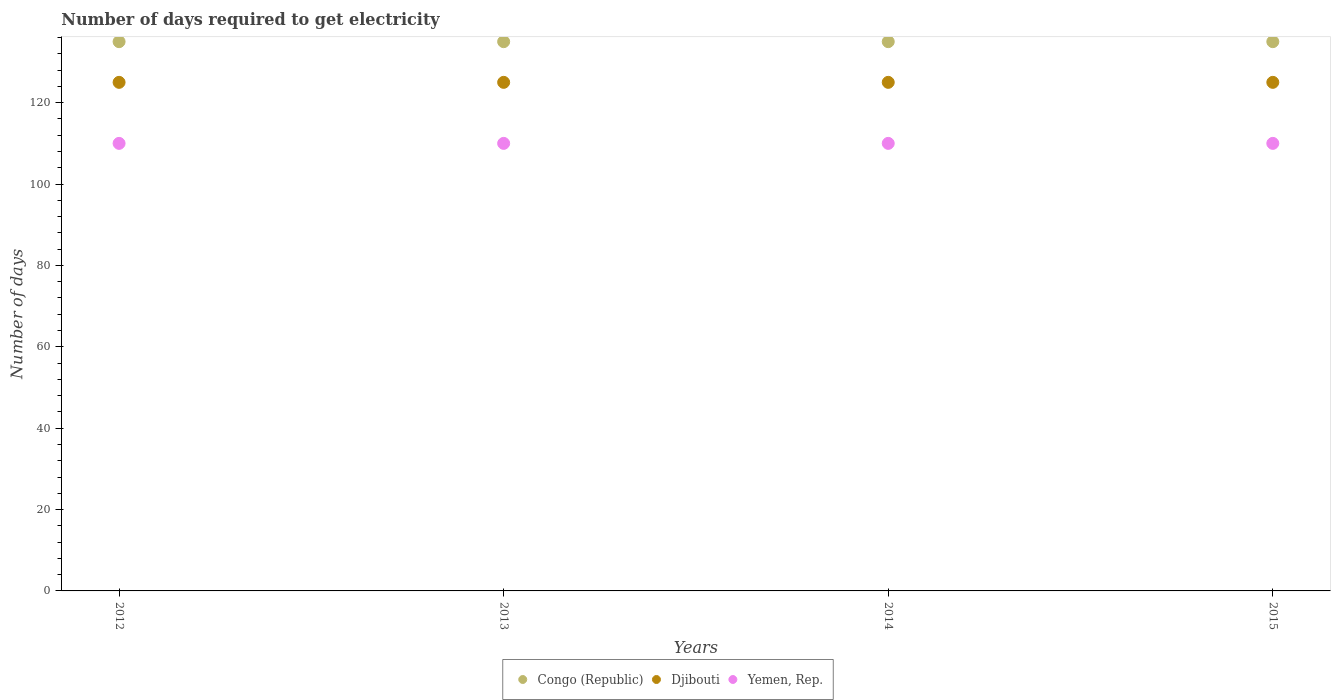How many different coloured dotlines are there?
Keep it short and to the point. 3. What is the number of days required to get electricity in in Congo (Republic) in 2015?
Offer a terse response. 135. Across all years, what is the maximum number of days required to get electricity in in Djibouti?
Ensure brevity in your answer.  125. Across all years, what is the minimum number of days required to get electricity in in Djibouti?
Your response must be concise. 125. In which year was the number of days required to get electricity in in Congo (Republic) maximum?
Your answer should be very brief. 2012. What is the total number of days required to get electricity in in Congo (Republic) in the graph?
Your answer should be very brief. 540. What is the difference between the number of days required to get electricity in in Yemen, Rep. in 2015 and the number of days required to get electricity in in Congo (Republic) in 2013?
Offer a very short reply. -25. What is the average number of days required to get electricity in in Congo (Republic) per year?
Ensure brevity in your answer.  135. In the year 2012, what is the difference between the number of days required to get electricity in in Congo (Republic) and number of days required to get electricity in in Yemen, Rep.?
Ensure brevity in your answer.  25. Is the difference between the number of days required to get electricity in in Congo (Republic) in 2013 and 2015 greater than the difference between the number of days required to get electricity in in Yemen, Rep. in 2013 and 2015?
Offer a very short reply. No. Is the sum of the number of days required to get electricity in in Djibouti in 2012 and 2015 greater than the maximum number of days required to get electricity in in Yemen, Rep. across all years?
Ensure brevity in your answer.  Yes. Does the number of days required to get electricity in in Djibouti monotonically increase over the years?
Offer a terse response. No. Is the number of days required to get electricity in in Congo (Republic) strictly greater than the number of days required to get electricity in in Yemen, Rep. over the years?
Make the answer very short. Yes. How many dotlines are there?
Make the answer very short. 3. What is the difference between two consecutive major ticks on the Y-axis?
Your answer should be very brief. 20. Does the graph contain grids?
Give a very brief answer. No. Where does the legend appear in the graph?
Your answer should be very brief. Bottom center. How are the legend labels stacked?
Offer a terse response. Horizontal. What is the title of the graph?
Provide a short and direct response. Number of days required to get electricity. Does "Peru" appear as one of the legend labels in the graph?
Ensure brevity in your answer.  No. What is the label or title of the X-axis?
Your answer should be compact. Years. What is the label or title of the Y-axis?
Ensure brevity in your answer.  Number of days. What is the Number of days of Congo (Republic) in 2012?
Offer a terse response. 135. What is the Number of days of Djibouti in 2012?
Offer a very short reply. 125. What is the Number of days of Yemen, Rep. in 2012?
Offer a terse response. 110. What is the Number of days of Congo (Republic) in 2013?
Your response must be concise. 135. What is the Number of days in Djibouti in 2013?
Provide a succinct answer. 125. What is the Number of days of Yemen, Rep. in 2013?
Your answer should be very brief. 110. What is the Number of days in Congo (Republic) in 2014?
Offer a terse response. 135. What is the Number of days of Djibouti in 2014?
Offer a terse response. 125. What is the Number of days of Yemen, Rep. in 2014?
Your answer should be very brief. 110. What is the Number of days in Congo (Republic) in 2015?
Make the answer very short. 135. What is the Number of days in Djibouti in 2015?
Offer a terse response. 125. What is the Number of days of Yemen, Rep. in 2015?
Give a very brief answer. 110. Across all years, what is the maximum Number of days of Congo (Republic)?
Offer a terse response. 135. Across all years, what is the maximum Number of days in Djibouti?
Give a very brief answer. 125. Across all years, what is the maximum Number of days of Yemen, Rep.?
Give a very brief answer. 110. Across all years, what is the minimum Number of days in Congo (Republic)?
Your response must be concise. 135. Across all years, what is the minimum Number of days of Djibouti?
Keep it short and to the point. 125. Across all years, what is the minimum Number of days of Yemen, Rep.?
Offer a very short reply. 110. What is the total Number of days in Congo (Republic) in the graph?
Provide a succinct answer. 540. What is the total Number of days in Yemen, Rep. in the graph?
Keep it short and to the point. 440. What is the difference between the Number of days of Congo (Republic) in 2012 and that in 2013?
Provide a short and direct response. 0. What is the difference between the Number of days in Congo (Republic) in 2012 and that in 2015?
Give a very brief answer. 0. What is the difference between the Number of days in Congo (Republic) in 2013 and that in 2015?
Provide a short and direct response. 0. What is the difference between the Number of days in Djibouti in 2013 and that in 2015?
Offer a terse response. 0. What is the difference between the Number of days of Yemen, Rep. in 2013 and that in 2015?
Give a very brief answer. 0. What is the difference between the Number of days in Congo (Republic) in 2014 and that in 2015?
Offer a terse response. 0. What is the difference between the Number of days in Djibouti in 2014 and that in 2015?
Offer a terse response. 0. What is the difference between the Number of days in Yemen, Rep. in 2014 and that in 2015?
Give a very brief answer. 0. What is the difference between the Number of days in Congo (Republic) in 2012 and the Number of days in Djibouti in 2013?
Keep it short and to the point. 10. What is the difference between the Number of days of Congo (Republic) in 2012 and the Number of days of Yemen, Rep. in 2013?
Provide a succinct answer. 25. What is the difference between the Number of days of Congo (Republic) in 2012 and the Number of days of Djibouti in 2014?
Ensure brevity in your answer.  10. What is the difference between the Number of days in Congo (Republic) in 2012 and the Number of days in Djibouti in 2015?
Offer a terse response. 10. What is the difference between the Number of days of Djibouti in 2012 and the Number of days of Yemen, Rep. in 2015?
Keep it short and to the point. 15. What is the difference between the Number of days in Congo (Republic) in 2013 and the Number of days in Djibouti in 2014?
Your answer should be compact. 10. What is the difference between the Number of days of Congo (Republic) in 2013 and the Number of days of Djibouti in 2015?
Give a very brief answer. 10. What is the difference between the Number of days of Congo (Republic) in 2013 and the Number of days of Yemen, Rep. in 2015?
Your answer should be compact. 25. What is the difference between the Number of days in Congo (Republic) in 2014 and the Number of days in Djibouti in 2015?
Your answer should be compact. 10. What is the difference between the Number of days of Djibouti in 2014 and the Number of days of Yemen, Rep. in 2015?
Give a very brief answer. 15. What is the average Number of days of Congo (Republic) per year?
Provide a short and direct response. 135. What is the average Number of days in Djibouti per year?
Keep it short and to the point. 125. What is the average Number of days in Yemen, Rep. per year?
Provide a short and direct response. 110. In the year 2012, what is the difference between the Number of days of Congo (Republic) and Number of days of Djibouti?
Provide a succinct answer. 10. In the year 2013, what is the difference between the Number of days in Congo (Republic) and Number of days in Djibouti?
Keep it short and to the point. 10. In the year 2014, what is the difference between the Number of days of Congo (Republic) and Number of days of Djibouti?
Your answer should be very brief. 10. In the year 2015, what is the difference between the Number of days of Congo (Republic) and Number of days of Yemen, Rep.?
Offer a terse response. 25. What is the ratio of the Number of days of Congo (Republic) in 2012 to that in 2014?
Your answer should be compact. 1. What is the ratio of the Number of days of Djibouti in 2012 to that in 2014?
Offer a very short reply. 1. What is the ratio of the Number of days of Yemen, Rep. in 2012 to that in 2014?
Offer a very short reply. 1. What is the ratio of the Number of days of Congo (Republic) in 2012 to that in 2015?
Give a very brief answer. 1. What is the ratio of the Number of days in Yemen, Rep. in 2012 to that in 2015?
Your response must be concise. 1. What is the ratio of the Number of days of Congo (Republic) in 2013 to that in 2014?
Provide a short and direct response. 1. What is the ratio of the Number of days in Djibouti in 2013 to that in 2014?
Provide a succinct answer. 1. What is the ratio of the Number of days of Congo (Republic) in 2013 to that in 2015?
Give a very brief answer. 1. What is the ratio of the Number of days of Congo (Republic) in 2014 to that in 2015?
Offer a terse response. 1. What is the ratio of the Number of days in Djibouti in 2014 to that in 2015?
Provide a succinct answer. 1. What is the difference between the highest and the second highest Number of days of Djibouti?
Give a very brief answer. 0. What is the difference between the highest and the second highest Number of days in Yemen, Rep.?
Ensure brevity in your answer.  0. What is the difference between the highest and the lowest Number of days in Djibouti?
Your answer should be compact. 0. 